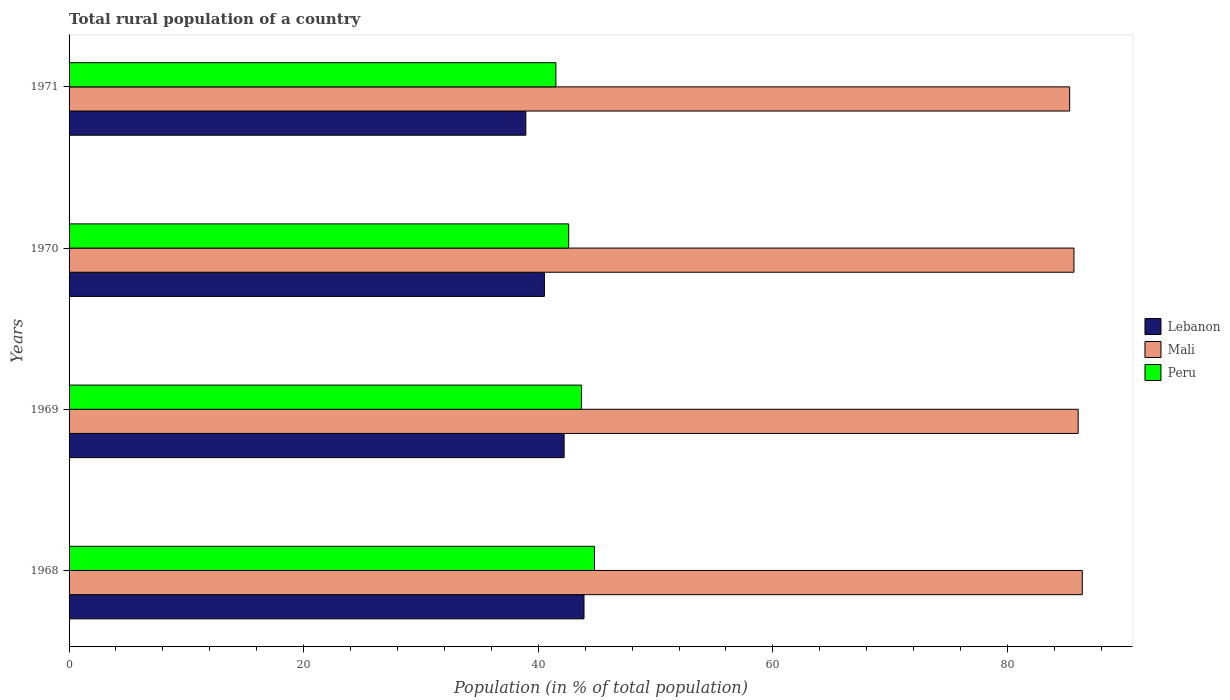How many groups of bars are there?
Make the answer very short. 4. Are the number of bars per tick equal to the number of legend labels?
Keep it short and to the point. Yes. How many bars are there on the 2nd tick from the bottom?
Your response must be concise. 3. What is the label of the 3rd group of bars from the top?
Your response must be concise. 1969. What is the rural population in Lebanon in 1970?
Ensure brevity in your answer.  40.52. Across all years, what is the maximum rural population in Lebanon?
Make the answer very short. 43.9. Across all years, what is the minimum rural population in Mali?
Provide a short and direct response. 85.3. In which year was the rural population in Lebanon maximum?
Keep it short and to the point. 1968. What is the total rural population in Peru in the graph?
Provide a short and direct response. 172.58. What is the difference between the rural population in Peru in 1968 and that in 1971?
Your answer should be compact. 3.29. What is the difference between the rural population in Lebanon in 1971 and the rural population in Mali in 1969?
Keep it short and to the point. -47.09. What is the average rural population in Peru per year?
Give a very brief answer. 43.15. In the year 1970, what is the difference between the rural population in Mali and rural population in Lebanon?
Give a very brief answer. 45.15. What is the ratio of the rural population in Peru in 1969 to that in 1970?
Ensure brevity in your answer.  1.03. Is the rural population in Lebanon in 1969 less than that in 1970?
Offer a very short reply. No. What is the difference between the highest and the second highest rural population in Mali?
Offer a very short reply. 0.35. What is the difference between the highest and the lowest rural population in Lebanon?
Make the answer very short. 4.96. What does the 2nd bar from the top in 1969 represents?
Provide a short and direct response. Mali. What does the 1st bar from the bottom in 1968 represents?
Your response must be concise. Lebanon. Is it the case that in every year, the sum of the rural population in Peru and rural population in Mali is greater than the rural population in Lebanon?
Your response must be concise. Yes. How many bars are there?
Offer a very short reply. 12. What is the difference between two consecutive major ticks on the X-axis?
Your answer should be compact. 20. Does the graph contain any zero values?
Ensure brevity in your answer.  No. Where does the legend appear in the graph?
Your answer should be very brief. Center right. What is the title of the graph?
Provide a succinct answer. Total rural population of a country. Does "Ukraine" appear as one of the legend labels in the graph?
Make the answer very short. No. What is the label or title of the X-axis?
Keep it short and to the point. Population (in % of total population). What is the label or title of the Y-axis?
Keep it short and to the point. Years. What is the Population (in % of total population) of Lebanon in 1968?
Give a very brief answer. 43.9. What is the Population (in % of total population) of Mali in 1968?
Make the answer very short. 86.38. What is the Population (in % of total population) in Peru in 1968?
Keep it short and to the point. 44.79. What is the Population (in % of total population) of Lebanon in 1969?
Your response must be concise. 42.2. What is the Population (in % of total population) in Mali in 1969?
Offer a very short reply. 86.03. What is the Population (in % of total population) in Peru in 1969?
Ensure brevity in your answer.  43.69. What is the Population (in % of total population) of Lebanon in 1970?
Your response must be concise. 40.52. What is the Population (in % of total population) of Mali in 1970?
Offer a terse response. 85.67. What is the Population (in % of total population) of Peru in 1970?
Give a very brief answer. 42.59. What is the Population (in % of total population) of Lebanon in 1971?
Your answer should be compact. 38.94. What is the Population (in % of total population) of Mali in 1971?
Offer a very short reply. 85.3. What is the Population (in % of total population) of Peru in 1971?
Your answer should be very brief. 41.5. Across all years, what is the maximum Population (in % of total population) in Lebanon?
Provide a succinct answer. 43.9. Across all years, what is the maximum Population (in % of total population) of Mali?
Make the answer very short. 86.38. Across all years, what is the maximum Population (in % of total population) in Peru?
Provide a short and direct response. 44.79. Across all years, what is the minimum Population (in % of total population) of Lebanon?
Ensure brevity in your answer.  38.94. Across all years, what is the minimum Population (in % of total population) of Mali?
Ensure brevity in your answer.  85.3. Across all years, what is the minimum Population (in % of total population) in Peru?
Your answer should be compact. 41.5. What is the total Population (in % of total population) in Lebanon in the graph?
Offer a very short reply. 165.57. What is the total Population (in % of total population) of Mali in the graph?
Your answer should be very brief. 343.38. What is the total Population (in % of total population) of Peru in the graph?
Offer a very short reply. 172.58. What is the difference between the Population (in % of total population) of Lebanon in 1968 and that in 1969?
Make the answer very short. 1.7. What is the difference between the Population (in % of total population) in Mali in 1968 and that in 1969?
Provide a succinct answer. 0.35. What is the difference between the Population (in % of total population) in Peru in 1968 and that in 1969?
Your response must be concise. 1.1. What is the difference between the Population (in % of total population) in Lebanon in 1968 and that in 1970?
Offer a terse response. 3.37. What is the difference between the Population (in % of total population) of Mali in 1968 and that in 1970?
Your response must be concise. 0.71. What is the difference between the Population (in % of total population) of Peru in 1968 and that in 1970?
Provide a succinct answer. 2.2. What is the difference between the Population (in % of total population) of Lebanon in 1968 and that in 1971?
Provide a succinct answer. 4.96. What is the difference between the Population (in % of total population) in Mali in 1968 and that in 1971?
Give a very brief answer. 1.08. What is the difference between the Population (in % of total population) in Peru in 1968 and that in 1971?
Give a very brief answer. 3.29. What is the difference between the Population (in % of total population) in Lebanon in 1969 and that in 1970?
Make the answer very short. 1.68. What is the difference between the Population (in % of total population) in Mali in 1969 and that in 1970?
Your answer should be very brief. 0.36. What is the difference between the Population (in % of total population) in Peru in 1969 and that in 1970?
Offer a terse response. 1.1. What is the difference between the Population (in % of total population) in Lebanon in 1969 and that in 1971?
Keep it short and to the point. 3.26. What is the difference between the Population (in % of total population) in Mali in 1969 and that in 1971?
Your answer should be very brief. 0.73. What is the difference between the Population (in % of total population) in Peru in 1969 and that in 1971?
Give a very brief answer. 2.19. What is the difference between the Population (in % of total population) in Lebanon in 1970 and that in 1971?
Your answer should be compact. 1.58. What is the difference between the Population (in % of total population) in Mali in 1970 and that in 1971?
Offer a very short reply. 0.37. What is the difference between the Population (in % of total population) of Peru in 1970 and that in 1971?
Make the answer very short. 1.09. What is the difference between the Population (in % of total population) in Lebanon in 1968 and the Population (in % of total population) in Mali in 1969?
Your answer should be compact. -42.13. What is the difference between the Population (in % of total population) in Lebanon in 1968 and the Population (in % of total population) in Peru in 1969?
Give a very brief answer. 0.21. What is the difference between the Population (in % of total population) in Mali in 1968 and the Population (in % of total population) in Peru in 1969?
Your answer should be compact. 42.69. What is the difference between the Population (in % of total population) in Lebanon in 1968 and the Population (in % of total population) in Mali in 1970?
Keep it short and to the point. -41.77. What is the difference between the Population (in % of total population) of Lebanon in 1968 and the Population (in % of total population) of Peru in 1970?
Give a very brief answer. 1.3. What is the difference between the Population (in % of total population) in Mali in 1968 and the Population (in % of total population) in Peru in 1970?
Your answer should be very brief. 43.79. What is the difference between the Population (in % of total population) of Lebanon in 1968 and the Population (in % of total population) of Mali in 1971?
Keep it short and to the point. -41.4. What is the difference between the Population (in % of total population) of Lebanon in 1968 and the Population (in % of total population) of Peru in 1971?
Give a very brief answer. 2.4. What is the difference between the Population (in % of total population) in Mali in 1968 and the Population (in % of total population) in Peru in 1971?
Offer a terse response. 44.88. What is the difference between the Population (in % of total population) of Lebanon in 1969 and the Population (in % of total population) of Mali in 1970?
Your answer should be very brief. -43.47. What is the difference between the Population (in % of total population) of Lebanon in 1969 and the Population (in % of total population) of Peru in 1970?
Your answer should be compact. -0.39. What is the difference between the Population (in % of total population) of Mali in 1969 and the Population (in % of total population) of Peru in 1970?
Keep it short and to the point. 43.44. What is the difference between the Population (in % of total population) in Lebanon in 1969 and the Population (in % of total population) in Mali in 1971?
Provide a succinct answer. -43.1. What is the difference between the Population (in % of total population) in Mali in 1969 and the Population (in % of total population) in Peru in 1971?
Make the answer very short. 44.52. What is the difference between the Population (in % of total population) in Lebanon in 1970 and the Population (in % of total population) in Mali in 1971?
Provide a short and direct response. -44.78. What is the difference between the Population (in % of total population) in Lebanon in 1970 and the Population (in % of total population) in Peru in 1971?
Your answer should be very brief. -0.98. What is the difference between the Population (in % of total population) in Mali in 1970 and the Population (in % of total population) in Peru in 1971?
Give a very brief answer. 44.17. What is the average Population (in % of total population) in Lebanon per year?
Provide a succinct answer. 41.39. What is the average Population (in % of total population) of Mali per year?
Keep it short and to the point. 85.85. What is the average Population (in % of total population) in Peru per year?
Offer a terse response. 43.15. In the year 1968, what is the difference between the Population (in % of total population) in Lebanon and Population (in % of total population) in Mali?
Your answer should be compact. -42.48. In the year 1968, what is the difference between the Population (in % of total population) of Lebanon and Population (in % of total population) of Peru?
Your response must be concise. -0.89. In the year 1968, what is the difference between the Population (in % of total population) of Mali and Population (in % of total population) of Peru?
Your answer should be compact. 41.59. In the year 1969, what is the difference between the Population (in % of total population) in Lebanon and Population (in % of total population) in Mali?
Keep it short and to the point. -43.83. In the year 1969, what is the difference between the Population (in % of total population) in Lebanon and Population (in % of total population) in Peru?
Make the answer very short. -1.49. In the year 1969, what is the difference between the Population (in % of total population) in Mali and Population (in % of total population) in Peru?
Your answer should be compact. 42.34. In the year 1970, what is the difference between the Population (in % of total population) of Lebanon and Population (in % of total population) of Mali?
Make the answer very short. -45.15. In the year 1970, what is the difference between the Population (in % of total population) of Lebanon and Population (in % of total population) of Peru?
Offer a terse response. -2.07. In the year 1970, what is the difference between the Population (in % of total population) in Mali and Population (in % of total population) in Peru?
Provide a succinct answer. 43.08. In the year 1971, what is the difference between the Population (in % of total population) in Lebanon and Population (in % of total population) in Mali?
Ensure brevity in your answer.  -46.36. In the year 1971, what is the difference between the Population (in % of total population) of Lebanon and Population (in % of total population) of Peru?
Offer a very short reply. -2.56. In the year 1971, what is the difference between the Population (in % of total population) in Mali and Population (in % of total population) in Peru?
Offer a terse response. 43.8. What is the ratio of the Population (in % of total population) of Lebanon in 1968 to that in 1969?
Ensure brevity in your answer.  1.04. What is the ratio of the Population (in % of total population) of Peru in 1968 to that in 1969?
Your answer should be very brief. 1.03. What is the ratio of the Population (in % of total population) in Lebanon in 1968 to that in 1970?
Give a very brief answer. 1.08. What is the ratio of the Population (in % of total population) of Mali in 1968 to that in 1970?
Make the answer very short. 1.01. What is the ratio of the Population (in % of total population) of Peru in 1968 to that in 1970?
Provide a succinct answer. 1.05. What is the ratio of the Population (in % of total population) in Lebanon in 1968 to that in 1971?
Keep it short and to the point. 1.13. What is the ratio of the Population (in % of total population) in Mali in 1968 to that in 1971?
Offer a terse response. 1.01. What is the ratio of the Population (in % of total population) of Peru in 1968 to that in 1971?
Offer a very short reply. 1.08. What is the ratio of the Population (in % of total population) in Lebanon in 1969 to that in 1970?
Offer a terse response. 1.04. What is the ratio of the Population (in % of total population) of Mali in 1969 to that in 1970?
Provide a short and direct response. 1. What is the ratio of the Population (in % of total population) of Peru in 1969 to that in 1970?
Ensure brevity in your answer.  1.03. What is the ratio of the Population (in % of total population) in Lebanon in 1969 to that in 1971?
Your response must be concise. 1.08. What is the ratio of the Population (in % of total population) in Mali in 1969 to that in 1971?
Your answer should be very brief. 1.01. What is the ratio of the Population (in % of total population) of Peru in 1969 to that in 1971?
Offer a terse response. 1.05. What is the ratio of the Population (in % of total population) of Lebanon in 1970 to that in 1971?
Provide a short and direct response. 1.04. What is the ratio of the Population (in % of total population) in Mali in 1970 to that in 1971?
Ensure brevity in your answer.  1. What is the ratio of the Population (in % of total population) in Peru in 1970 to that in 1971?
Offer a terse response. 1.03. What is the difference between the highest and the second highest Population (in % of total population) of Lebanon?
Your answer should be very brief. 1.7. What is the difference between the highest and the second highest Population (in % of total population) in Mali?
Keep it short and to the point. 0.35. What is the difference between the highest and the second highest Population (in % of total population) of Peru?
Ensure brevity in your answer.  1.1. What is the difference between the highest and the lowest Population (in % of total population) in Lebanon?
Offer a terse response. 4.96. What is the difference between the highest and the lowest Population (in % of total population) of Mali?
Offer a very short reply. 1.08. What is the difference between the highest and the lowest Population (in % of total population) in Peru?
Offer a very short reply. 3.29. 